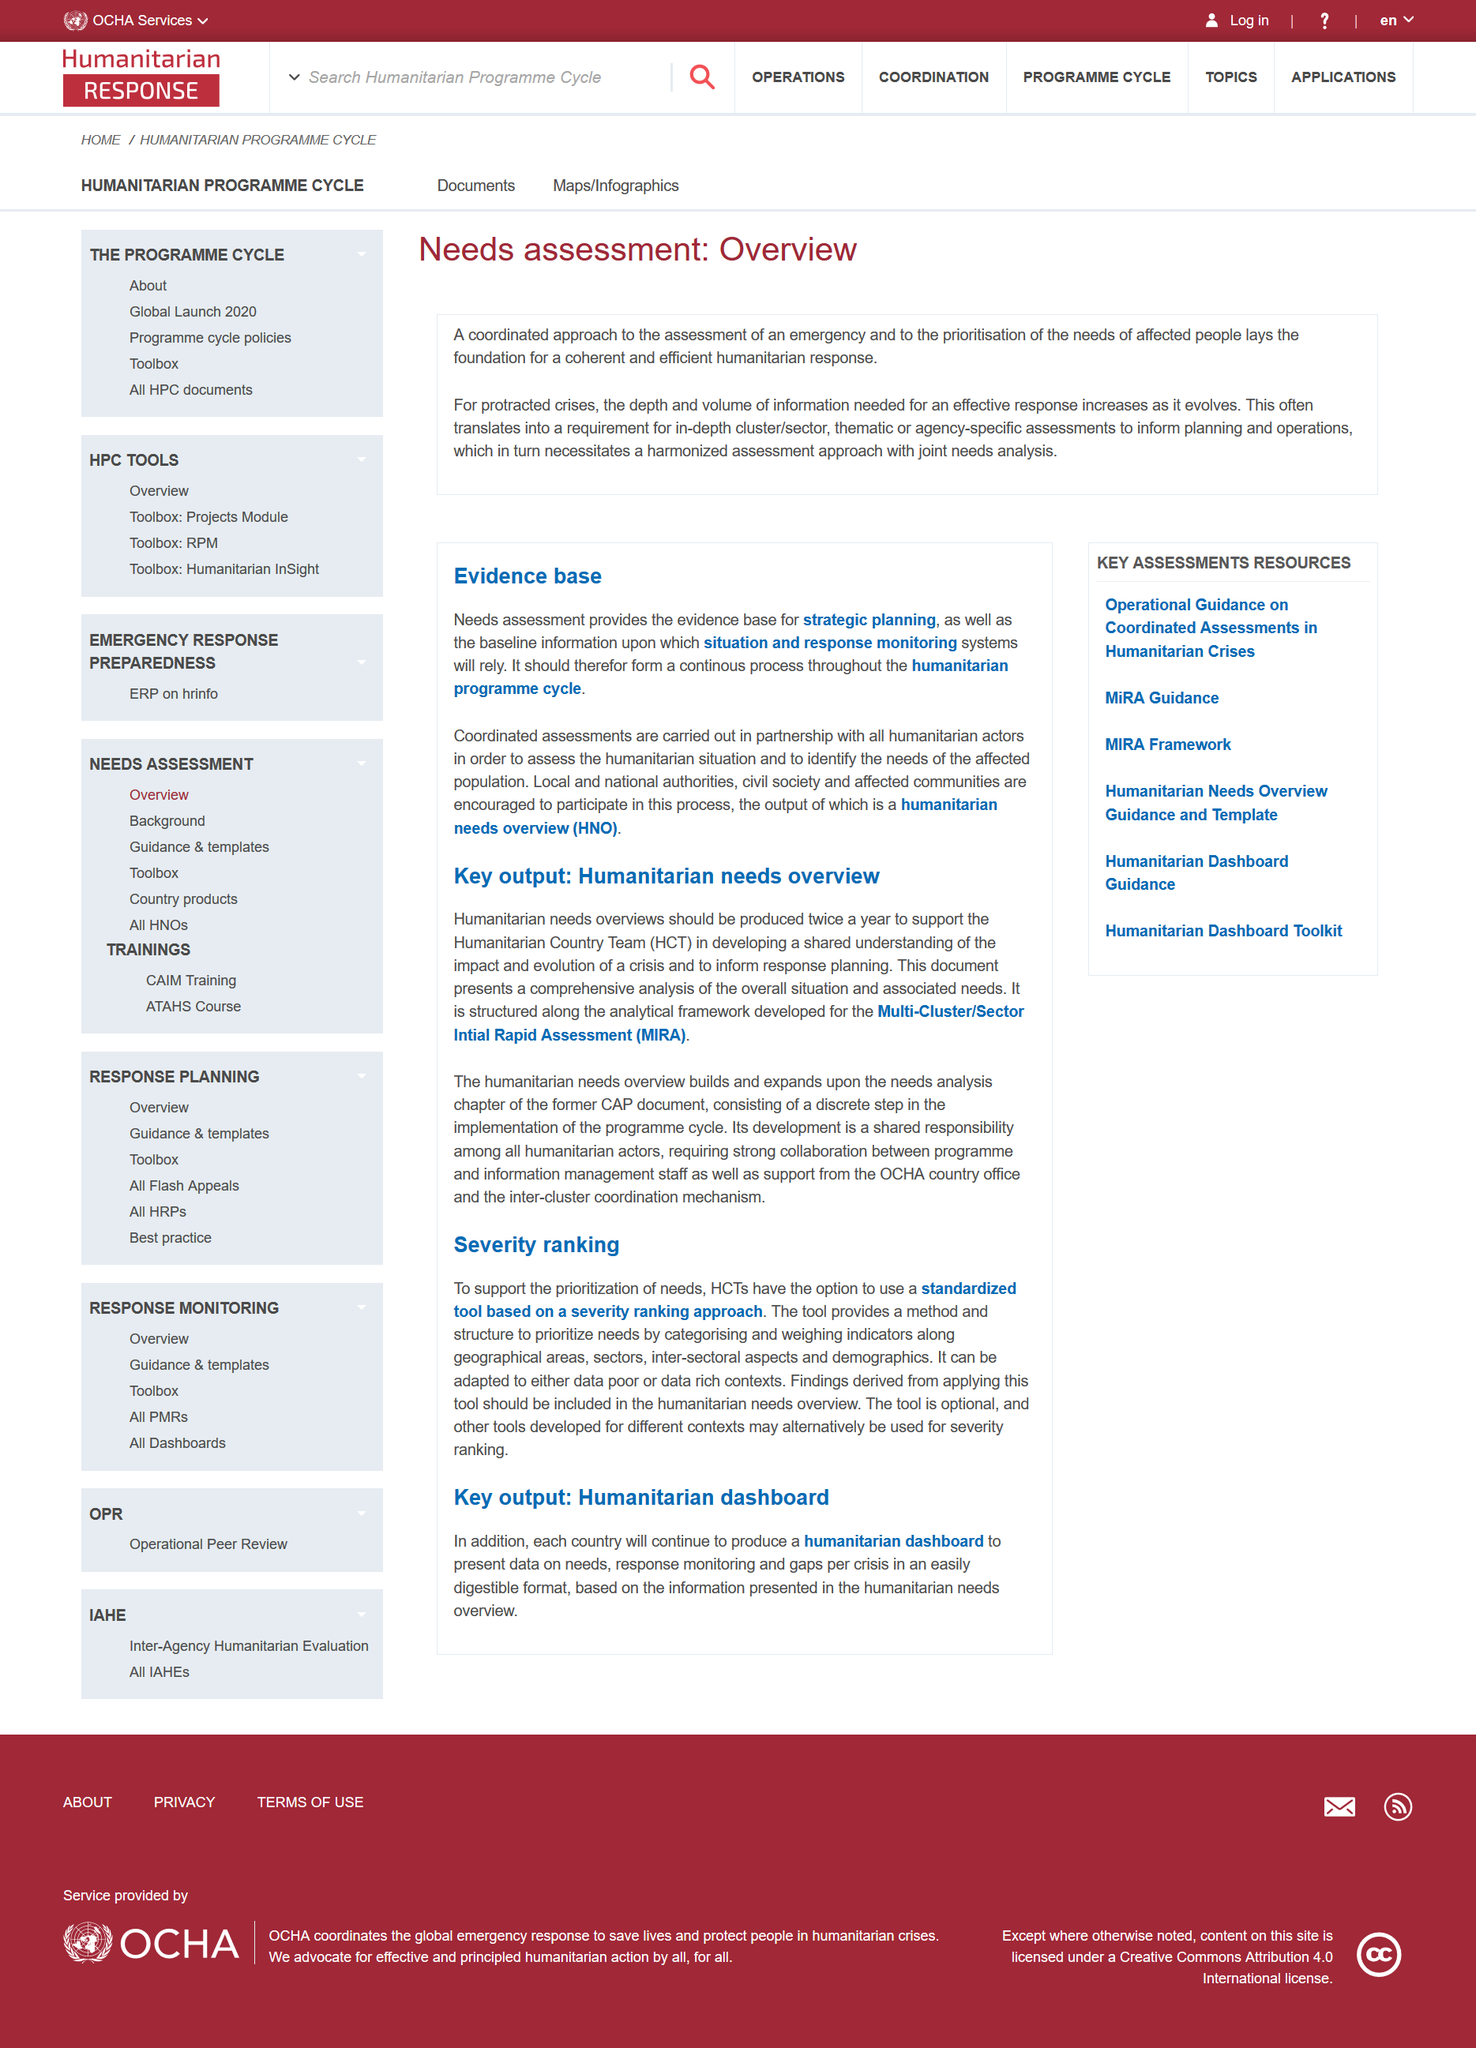Give some essential details in this illustration. The assessment serves as a foundation for a well-organized and effective humanitarian response. This is a humanitarian overview, which is a part of a report. The acronym "HCT" represents the Humanitarian Country Team, a collective grouping of organizations and individuals involved in humanitarian efforts and assistance in various countries. Each country will continue to produce a humanitarian dashboard to monitor and track humanitarian needs and response efforts in a comprehensive and user-friendly manner. The humanitarian dashboard will present data on the current needs of affected populations, the effectiveness of response efforts, and areas where additional support is required per crisis situation. 